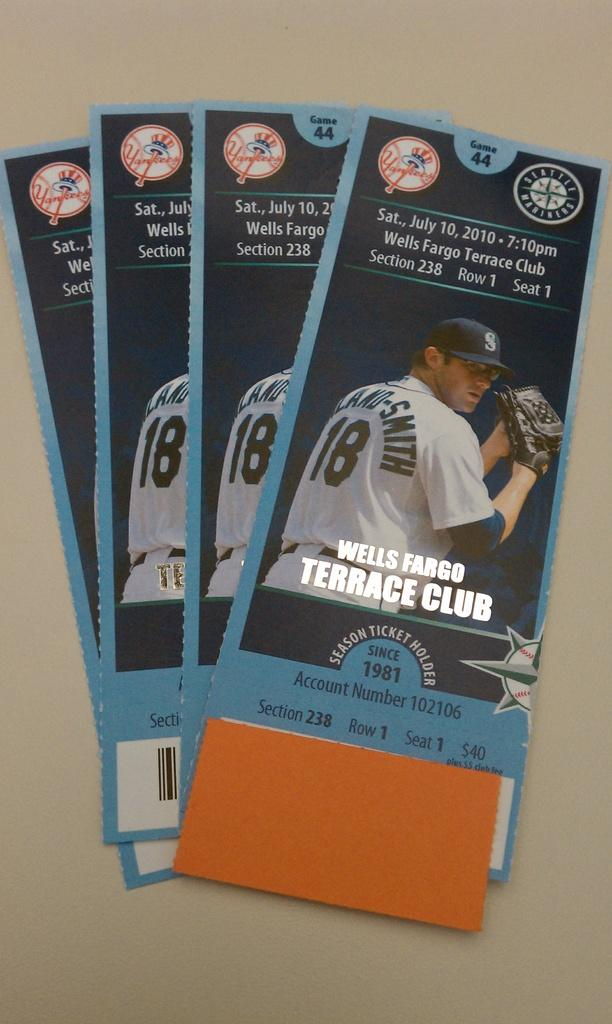<image>
Write a terse but informative summary of the picture. A stack of baseball tickets for the Seattle Mariners game on July 10, 2010. 